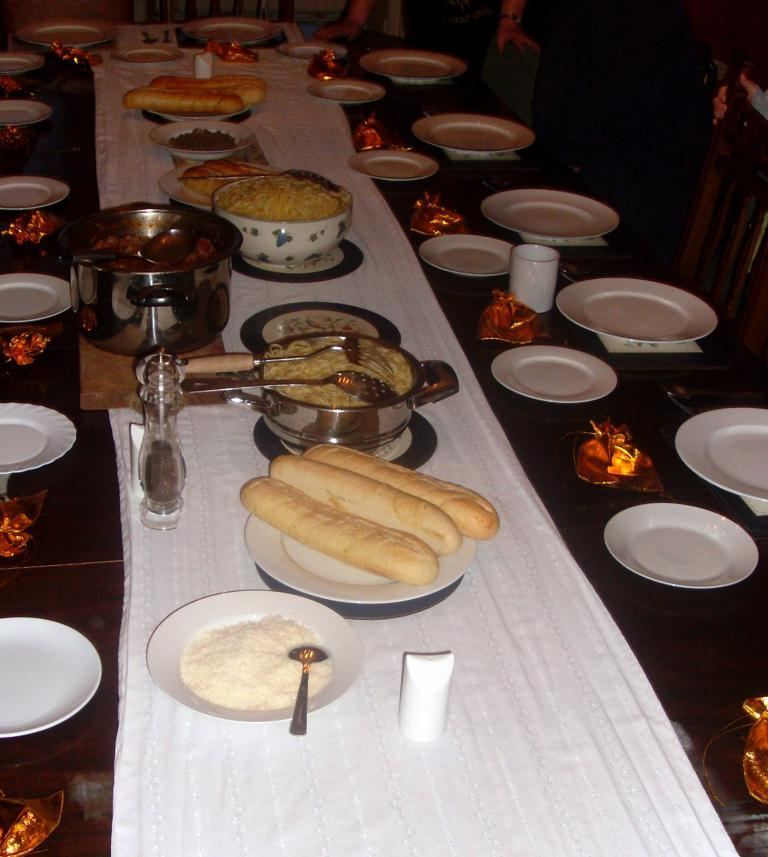What type of food can be seen in the image? There is food in the image, but the specific type cannot be determined from the facts provided. What objects are used for holding or serving food in the image? There are plates and spoons in the image that can be used for holding or serving food. What objects are used for drinking in the image? There are glasses in the image that can be used for drinking. What objects are used for carrying or storing items in the image? There are pouches in the image that can be used for carrying or storing items. What material is present in the image for covering or wiping? There is cloth in the image that can be used for covering or wiping. What objects are used for cooking or preparing food in the image? There are pans in the image that can be used for cooking or preparing food. Where are the objects located in the image? The objects are on a table in the image. What can be seen in the background of the image? There is a group of people and chairs in the background of the image. What type of stamp can be seen on the food in the image? There is no stamp present on the food in the image. How many feet are visible in the image? There is no mention of feet in the image, as it primarily features objects related to food and dining. 